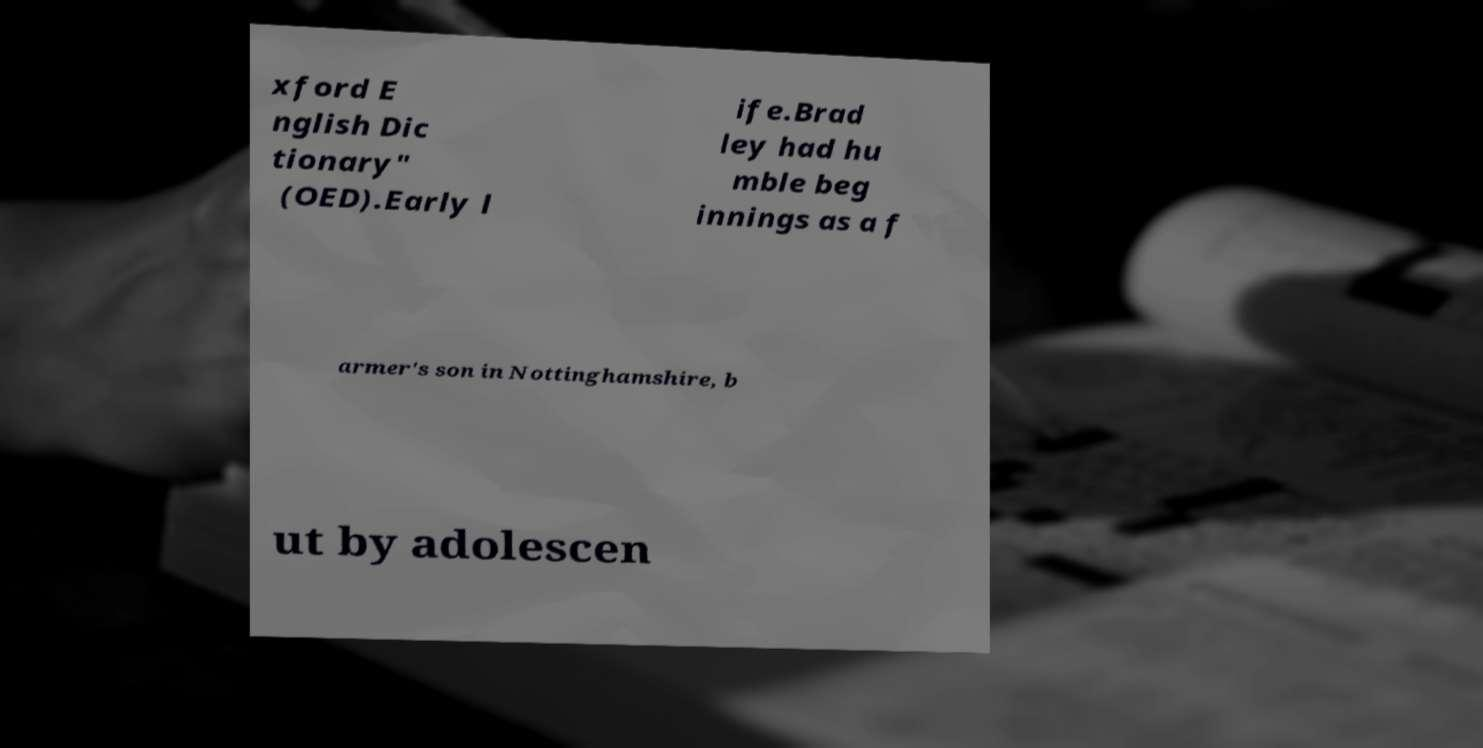Please read and relay the text visible in this image. What does it say? xford E nglish Dic tionary" (OED).Early l ife.Brad ley had hu mble beg innings as a f armer's son in Nottinghamshire, b ut by adolescen 